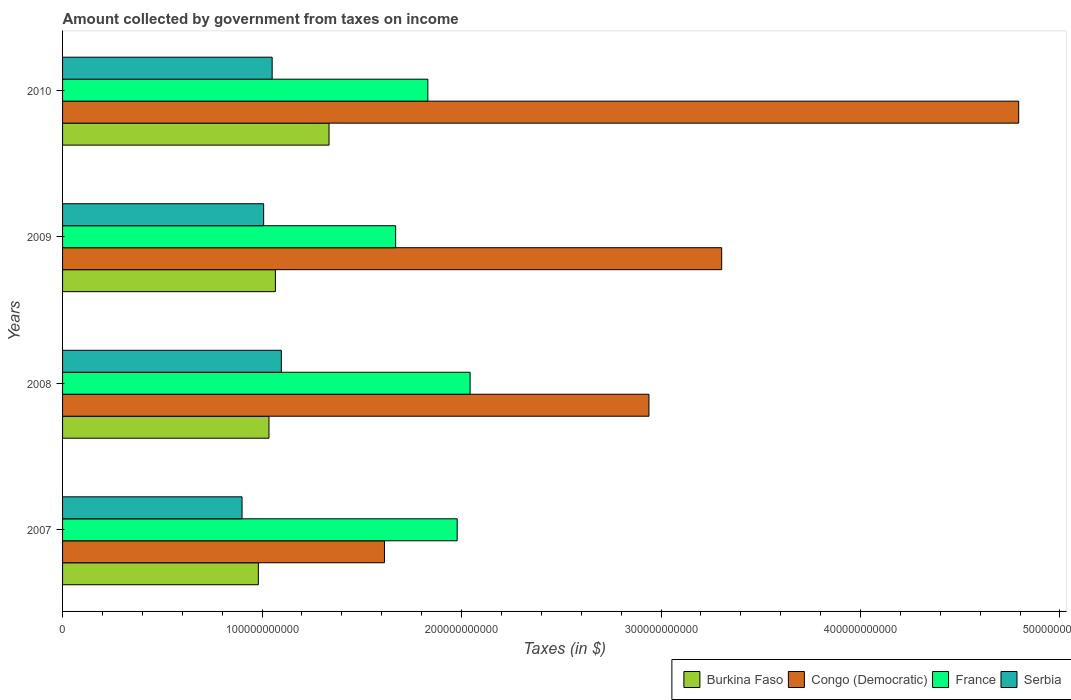How many different coloured bars are there?
Offer a terse response. 4. How many groups of bars are there?
Your response must be concise. 4. In how many cases, is the number of bars for a given year not equal to the number of legend labels?
Your response must be concise. 0. What is the amount collected by government from taxes on income in France in 2009?
Your answer should be compact. 1.67e+11. Across all years, what is the maximum amount collected by government from taxes on income in Burkina Faso?
Offer a very short reply. 1.34e+11. Across all years, what is the minimum amount collected by government from taxes on income in France?
Ensure brevity in your answer.  1.67e+11. In which year was the amount collected by government from taxes on income in Serbia minimum?
Keep it short and to the point. 2007. What is the total amount collected by government from taxes on income in Congo (Democratic) in the graph?
Keep it short and to the point. 1.27e+12. What is the difference between the amount collected by government from taxes on income in Serbia in 2007 and that in 2009?
Ensure brevity in your answer.  -1.08e+1. What is the difference between the amount collected by government from taxes on income in France in 2010 and the amount collected by government from taxes on income in Congo (Democratic) in 2008?
Give a very brief answer. -1.11e+11. What is the average amount collected by government from taxes on income in Congo (Democratic) per year?
Offer a very short reply. 3.16e+11. In the year 2010, what is the difference between the amount collected by government from taxes on income in France and amount collected by government from taxes on income in Serbia?
Provide a short and direct response. 7.80e+1. What is the ratio of the amount collected by government from taxes on income in Burkina Faso in 2008 to that in 2009?
Your answer should be compact. 0.97. Is the amount collected by government from taxes on income in France in 2007 less than that in 2009?
Your answer should be very brief. No. What is the difference between the highest and the second highest amount collected by government from taxes on income in Burkina Faso?
Provide a succinct answer. 2.69e+1. What is the difference between the highest and the lowest amount collected by government from taxes on income in France?
Provide a succinct answer. 3.73e+1. Is the sum of the amount collected by government from taxes on income in Burkina Faso in 2007 and 2008 greater than the maximum amount collected by government from taxes on income in France across all years?
Provide a short and direct response. No. Is it the case that in every year, the sum of the amount collected by government from taxes on income in Congo (Democratic) and amount collected by government from taxes on income in Burkina Faso is greater than the sum of amount collected by government from taxes on income in France and amount collected by government from taxes on income in Serbia?
Make the answer very short. Yes. What does the 4th bar from the top in 2007 represents?
Ensure brevity in your answer.  Burkina Faso. What does the 2nd bar from the bottom in 2008 represents?
Your answer should be compact. Congo (Democratic). Is it the case that in every year, the sum of the amount collected by government from taxes on income in Burkina Faso and amount collected by government from taxes on income in Congo (Democratic) is greater than the amount collected by government from taxes on income in France?
Provide a succinct answer. Yes. Are all the bars in the graph horizontal?
Provide a short and direct response. Yes. What is the difference between two consecutive major ticks on the X-axis?
Your answer should be compact. 1.00e+11. What is the title of the graph?
Make the answer very short. Amount collected by government from taxes on income. What is the label or title of the X-axis?
Provide a short and direct response. Taxes (in $). What is the label or title of the Y-axis?
Keep it short and to the point. Years. What is the Taxes (in $) of Burkina Faso in 2007?
Make the answer very short. 9.82e+1. What is the Taxes (in $) of Congo (Democratic) in 2007?
Your answer should be very brief. 1.61e+11. What is the Taxes (in $) of France in 2007?
Provide a succinct answer. 1.98e+11. What is the Taxes (in $) in Serbia in 2007?
Offer a very short reply. 9.00e+1. What is the Taxes (in $) in Burkina Faso in 2008?
Your answer should be compact. 1.03e+11. What is the Taxes (in $) of Congo (Democratic) in 2008?
Keep it short and to the point. 2.94e+11. What is the Taxes (in $) of France in 2008?
Provide a short and direct response. 2.04e+11. What is the Taxes (in $) in Serbia in 2008?
Offer a terse response. 1.10e+11. What is the Taxes (in $) of Burkina Faso in 2009?
Give a very brief answer. 1.07e+11. What is the Taxes (in $) in Congo (Democratic) in 2009?
Your response must be concise. 3.30e+11. What is the Taxes (in $) in France in 2009?
Your response must be concise. 1.67e+11. What is the Taxes (in $) in Serbia in 2009?
Your answer should be very brief. 1.01e+11. What is the Taxes (in $) in Burkina Faso in 2010?
Your answer should be very brief. 1.34e+11. What is the Taxes (in $) of Congo (Democratic) in 2010?
Ensure brevity in your answer.  4.79e+11. What is the Taxes (in $) in France in 2010?
Make the answer very short. 1.83e+11. What is the Taxes (in $) in Serbia in 2010?
Make the answer very short. 1.05e+11. Across all years, what is the maximum Taxes (in $) in Burkina Faso?
Your response must be concise. 1.34e+11. Across all years, what is the maximum Taxes (in $) of Congo (Democratic)?
Give a very brief answer. 4.79e+11. Across all years, what is the maximum Taxes (in $) of France?
Give a very brief answer. 2.04e+11. Across all years, what is the maximum Taxes (in $) in Serbia?
Your answer should be very brief. 1.10e+11. Across all years, what is the minimum Taxes (in $) in Burkina Faso?
Keep it short and to the point. 9.82e+1. Across all years, what is the minimum Taxes (in $) of Congo (Democratic)?
Keep it short and to the point. 1.61e+11. Across all years, what is the minimum Taxes (in $) of France?
Your answer should be very brief. 1.67e+11. Across all years, what is the minimum Taxes (in $) of Serbia?
Make the answer very short. 9.00e+1. What is the total Taxes (in $) in Burkina Faso in the graph?
Your answer should be very brief. 4.42e+11. What is the total Taxes (in $) in Congo (Democratic) in the graph?
Keep it short and to the point. 1.27e+12. What is the total Taxes (in $) in France in the graph?
Keep it short and to the point. 7.52e+11. What is the total Taxes (in $) of Serbia in the graph?
Offer a terse response. 4.06e+11. What is the difference between the Taxes (in $) in Burkina Faso in 2007 and that in 2008?
Ensure brevity in your answer.  -5.32e+09. What is the difference between the Taxes (in $) of Congo (Democratic) in 2007 and that in 2008?
Keep it short and to the point. -1.33e+11. What is the difference between the Taxes (in $) in France in 2007 and that in 2008?
Ensure brevity in your answer.  -6.48e+09. What is the difference between the Taxes (in $) in Serbia in 2007 and that in 2008?
Offer a terse response. -1.97e+1. What is the difference between the Taxes (in $) in Burkina Faso in 2007 and that in 2009?
Your response must be concise. -8.54e+09. What is the difference between the Taxes (in $) in Congo (Democratic) in 2007 and that in 2009?
Make the answer very short. -1.69e+11. What is the difference between the Taxes (in $) of France in 2007 and that in 2009?
Provide a succinct answer. 3.08e+1. What is the difference between the Taxes (in $) in Serbia in 2007 and that in 2009?
Ensure brevity in your answer.  -1.08e+1. What is the difference between the Taxes (in $) of Burkina Faso in 2007 and that in 2010?
Your answer should be compact. -3.54e+1. What is the difference between the Taxes (in $) of Congo (Democratic) in 2007 and that in 2010?
Your answer should be compact. -3.18e+11. What is the difference between the Taxes (in $) in France in 2007 and that in 2010?
Your answer should be very brief. 1.47e+1. What is the difference between the Taxes (in $) in Serbia in 2007 and that in 2010?
Your answer should be compact. -1.51e+1. What is the difference between the Taxes (in $) of Burkina Faso in 2008 and that in 2009?
Ensure brevity in your answer.  -3.22e+09. What is the difference between the Taxes (in $) of Congo (Democratic) in 2008 and that in 2009?
Your answer should be very brief. -3.65e+1. What is the difference between the Taxes (in $) in France in 2008 and that in 2009?
Your answer should be very brief. 3.73e+1. What is the difference between the Taxes (in $) of Serbia in 2008 and that in 2009?
Your answer should be compact. 8.86e+09. What is the difference between the Taxes (in $) of Burkina Faso in 2008 and that in 2010?
Offer a very short reply. -3.01e+1. What is the difference between the Taxes (in $) in Congo (Democratic) in 2008 and that in 2010?
Your answer should be very brief. -1.85e+11. What is the difference between the Taxes (in $) of France in 2008 and that in 2010?
Ensure brevity in your answer.  2.12e+1. What is the difference between the Taxes (in $) in Serbia in 2008 and that in 2010?
Your answer should be very brief. 4.60e+09. What is the difference between the Taxes (in $) of Burkina Faso in 2009 and that in 2010?
Provide a short and direct response. -2.69e+1. What is the difference between the Taxes (in $) in Congo (Democratic) in 2009 and that in 2010?
Your answer should be very brief. -1.49e+11. What is the difference between the Taxes (in $) of France in 2009 and that in 2010?
Give a very brief answer. -1.61e+1. What is the difference between the Taxes (in $) of Serbia in 2009 and that in 2010?
Make the answer very short. -4.26e+09. What is the difference between the Taxes (in $) of Burkina Faso in 2007 and the Taxes (in $) of Congo (Democratic) in 2008?
Your answer should be very brief. -1.96e+11. What is the difference between the Taxes (in $) of Burkina Faso in 2007 and the Taxes (in $) of France in 2008?
Your answer should be compact. -1.06e+11. What is the difference between the Taxes (in $) in Burkina Faso in 2007 and the Taxes (in $) in Serbia in 2008?
Ensure brevity in your answer.  -1.15e+1. What is the difference between the Taxes (in $) in Congo (Democratic) in 2007 and the Taxes (in $) in France in 2008?
Your response must be concise. -4.29e+1. What is the difference between the Taxes (in $) in Congo (Democratic) in 2007 and the Taxes (in $) in Serbia in 2008?
Provide a short and direct response. 5.17e+1. What is the difference between the Taxes (in $) in France in 2007 and the Taxes (in $) in Serbia in 2008?
Offer a terse response. 8.82e+1. What is the difference between the Taxes (in $) of Burkina Faso in 2007 and the Taxes (in $) of Congo (Democratic) in 2009?
Your response must be concise. -2.32e+11. What is the difference between the Taxes (in $) in Burkina Faso in 2007 and the Taxes (in $) in France in 2009?
Offer a very short reply. -6.88e+1. What is the difference between the Taxes (in $) of Burkina Faso in 2007 and the Taxes (in $) of Serbia in 2009?
Your answer should be very brief. -2.65e+09. What is the difference between the Taxes (in $) of Congo (Democratic) in 2007 and the Taxes (in $) of France in 2009?
Your answer should be very brief. -5.61e+09. What is the difference between the Taxes (in $) in Congo (Democratic) in 2007 and the Taxes (in $) in Serbia in 2009?
Make the answer very short. 6.06e+1. What is the difference between the Taxes (in $) in France in 2007 and the Taxes (in $) in Serbia in 2009?
Ensure brevity in your answer.  9.70e+1. What is the difference between the Taxes (in $) of Burkina Faso in 2007 and the Taxes (in $) of Congo (Democratic) in 2010?
Provide a succinct answer. -3.81e+11. What is the difference between the Taxes (in $) in Burkina Faso in 2007 and the Taxes (in $) in France in 2010?
Your response must be concise. -8.50e+1. What is the difference between the Taxes (in $) in Burkina Faso in 2007 and the Taxes (in $) in Serbia in 2010?
Give a very brief answer. -6.92e+09. What is the difference between the Taxes (in $) in Congo (Democratic) in 2007 and the Taxes (in $) in France in 2010?
Your response must be concise. -2.17e+1. What is the difference between the Taxes (in $) in Congo (Democratic) in 2007 and the Taxes (in $) in Serbia in 2010?
Offer a terse response. 5.63e+1. What is the difference between the Taxes (in $) in France in 2007 and the Taxes (in $) in Serbia in 2010?
Your answer should be compact. 9.28e+1. What is the difference between the Taxes (in $) of Burkina Faso in 2008 and the Taxes (in $) of Congo (Democratic) in 2009?
Offer a very short reply. -2.27e+11. What is the difference between the Taxes (in $) of Burkina Faso in 2008 and the Taxes (in $) of France in 2009?
Your answer should be very brief. -6.35e+1. What is the difference between the Taxes (in $) of Burkina Faso in 2008 and the Taxes (in $) of Serbia in 2009?
Give a very brief answer. 2.67e+09. What is the difference between the Taxes (in $) of Congo (Democratic) in 2008 and the Taxes (in $) of France in 2009?
Make the answer very short. 1.27e+11. What is the difference between the Taxes (in $) of Congo (Democratic) in 2008 and the Taxes (in $) of Serbia in 2009?
Keep it short and to the point. 1.93e+11. What is the difference between the Taxes (in $) in France in 2008 and the Taxes (in $) in Serbia in 2009?
Provide a succinct answer. 1.03e+11. What is the difference between the Taxes (in $) in Burkina Faso in 2008 and the Taxes (in $) in Congo (Democratic) in 2010?
Your response must be concise. -3.76e+11. What is the difference between the Taxes (in $) of Burkina Faso in 2008 and the Taxes (in $) of France in 2010?
Provide a succinct answer. -7.96e+1. What is the difference between the Taxes (in $) of Burkina Faso in 2008 and the Taxes (in $) of Serbia in 2010?
Provide a short and direct response. -1.60e+09. What is the difference between the Taxes (in $) in Congo (Democratic) in 2008 and the Taxes (in $) in France in 2010?
Provide a succinct answer. 1.11e+11. What is the difference between the Taxes (in $) in Congo (Democratic) in 2008 and the Taxes (in $) in Serbia in 2010?
Offer a terse response. 1.89e+11. What is the difference between the Taxes (in $) in France in 2008 and the Taxes (in $) in Serbia in 2010?
Provide a succinct answer. 9.92e+1. What is the difference between the Taxes (in $) of Burkina Faso in 2009 and the Taxes (in $) of Congo (Democratic) in 2010?
Ensure brevity in your answer.  -3.73e+11. What is the difference between the Taxes (in $) in Burkina Faso in 2009 and the Taxes (in $) in France in 2010?
Offer a very short reply. -7.64e+1. What is the difference between the Taxes (in $) of Burkina Faso in 2009 and the Taxes (in $) of Serbia in 2010?
Your answer should be compact. 1.62e+09. What is the difference between the Taxes (in $) in Congo (Democratic) in 2009 and the Taxes (in $) in France in 2010?
Keep it short and to the point. 1.47e+11. What is the difference between the Taxes (in $) in Congo (Democratic) in 2009 and the Taxes (in $) in Serbia in 2010?
Keep it short and to the point. 2.25e+11. What is the difference between the Taxes (in $) of France in 2009 and the Taxes (in $) of Serbia in 2010?
Your answer should be compact. 6.19e+1. What is the average Taxes (in $) in Burkina Faso per year?
Your answer should be very brief. 1.10e+11. What is the average Taxes (in $) of Congo (Democratic) per year?
Offer a terse response. 3.16e+11. What is the average Taxes (in $) in France per year?
Make the answer very short. 1.88e+11. What is the average Taxes (in $) in Serbia per year?
Your response must be concise. 1.01e+11. In the year 2007, what is the difference between the Taxes (in $) in Burkina Faso and Taxes (in $) in Congo (Democratic)?
Your response must be concise. -6.32e+1. In the year 2007, what is the difference between the Taxes (in $) of Burkina Faso and Taxes (in $) of France?
Your response must be concise. -9.97e+1. In the year 2007, what is the difference between the Taxes (in $) in Burkina Faso and Taxes (in $) in Serbia?
Keep it short and to the point. 8.18e+09. In the year 2007, what is the difference between the Taxes (in $) of Congo (Democratic) and Taxes (in $) of France?
Ensure brevity in your answer.  -3.64e+1. In the year 2007, what is the difference between the Taxes (in $) in Congo (Democratic) and Taxes (in $) in Serbia?
Your answer should be very brief. 7.14e+1. In the year 2007, what is the difference between the Taxes (in $) of France and Taxes (in $) of Serbia?
Provide a succinct answer. 1.08e+11. In the year 2008, what is the difference between the Taxes (in $) in Burkina Faso and Taxes (in $) in Congo (Democratic)?
Ensure brevity in your answer.  -1.90e+11. In the year 2008, what is the difference between the Taxes (in $) of Burkina Faso and Taxes (in $) of France?
Make the answer very short. -1.01e+11. In the year 2008, what is the difference between the Taxes (in $) in Burkina Faso and Taxes (in $) in Serbia?
Your response must be concise. -6.19e+09. In the year 2008, what is the difference between the Taxes (in $) of Congo (Democratic) and Taxes (in $) of France?
Your answer should be very brief. 8.97e+1. In the year 2008, what is the difference between the Taxes (in $) of Congo (Democratic) and Taxes (in $) of Serbia?
Your answer should be very brief. 1.84e+11. In the year 2008, what is the difference between the Taxes (in $) in France and Taxes (in $) in Serbia?
Ensure brevity in your answer.  9.46e+1. In the year 2009, what is the difference between the Taxes (in $) of Burkina Faso and Taxes (in $) of Congo (Democratic)?
Provide a short and direct response. -2.24e+11. In the year 2009, what is the difference between the Taxes (in $) in Burkina Faso and Taxes (in $) in France?
Your answer should be very brief. -6.03e+1. In the year 2009, what is the difference between the Taxes (in $) of Burkina Faso and Taxes (in $) of Serbia?
Provide a short and direct response. 5.88e+09. In the year 2009, what is the difference between the Taxes (in $) in Congo (Democratic) and Taxes (in $) in France?
Provide a short and direct response. 1.63e+11. In the year 2009, what is the difference between the Taxes (in $) of Congo (Democratic) and Taxes (in $) of Serbia?
Keep it short and to the point. 2.30e+11. In the year 2009, what is the difference between the Taxes (in $) of France and Taxes (in $) of Serbia?
Ensure brevity in your answer.  6.62e+1. In the year 2010, what is the difference between the Taxes (in $) of Burkina Faso and Taxes (in $) of Congo (Democratic)?
Give a very brief answer. -3.46e+11. In the year 2010, what is the difference between the Taxes (in $) in Burkina Faso and Taxes (in $) in France?
Provide a succinct answer. -4.95e+1. In the year 2010, what is the difference between the Taxes (in $) of Burkina Faso and Taxes (in $) of Serbia?
Your answer should be compact. 2.85e+1. In the year 2010, what is the difference between the Taxes (in $) in Congo (Democratic) and Taxes (in $) in France?
Ensure brevity in your answer.  2.96e+11. In the year 2010, what is the difference between the Taxes (in $) in Congo (Democratic) and Taxes (in $) in Serbia?
Offer a terse response. 3.74e+11. In the year 2010, what is the difference between the Taxes (in $) of France and Taxes (in $) of Serbia?
Make the answer very short. 7.80e+1. What is the ratio of the Taxes (in $) of Burkina Faso in 2007 to that in 2008?
Your answer should be very brief. 0.95. What is the ratio of the Taxes (in $) of Congo (Democratic) in 2007 to that in 2008?
Provide a short and direct response. 0.55. What is the ratio of the Taxes (in $) of France in 2007 to that in 2008?
Keep it short and to the point. 0.97. What is the ratio of the Taxes (in $) in Serbia in 2007 to that in 2008?
Give a very brief answer. 0.82. What is the ratio of the Taxes (in $) of Congo (Democratic) in 2007 to that in 2009?
Keep it short and to the point. 0.49. What is the ratio of the Taxes (in $) in France in 2007 to that in 2009?
Provide a succinct answer. 1.18. What is the ratio of the Taxes (in $) of Serbia in 2007 to that in 2009?
Ensure brevity in your answer.  0.89. What is the ratio of the Taxes (in $) in Burkina Faso in 2007 to that in 2010?
Your response must be concise. 0.73. What is the ratio of the Taxes (in $) in Congo (Democratic) in 2007 to that in 2010?
Make the answer very short. 0.34. What is the ratio of the Taxes (in $) of France in 2007 to that in 2010?
Ensure brevity in your answer.  1.08. What is the ratio of the Taxes (in $) in Serbia in 2007 to that in 2010?
Give a very brief answer. 0.86. What is the ratio of the Taxes (in $) of Burkina Faso in 2008 to that in 2009?
Make the answer very short. 0.97. What is the ratio of the Taxes (in $) in Congo (Democratic) in 2008 to that in 2009?
Provide a succinct answer. 0.89. What is the ratio of the Taxes (in $) in France in 2008 to that in 2009?
Offer a very short reply. 1.22. What is the ratio of the Taxes (in $) of Serbia in 2008 to that in 2009?
Keep it short and to the point. 1.09. What is the ratio of the Taxes (in $) in Burkina Faso in 2008 to that in 2010?
Your answer should be very brief. 0.77. What is the ratio of the Taxes (in $) of Congo (Democratic) in 2008 to that in 2010?
Your answer should be very brief. 0.61. What is the ratio of the Taxes (in $) of France in 2008 to that in 2010?
Offer a very short reply. 1.12. What is the ratio of the Taxes (in $) in Serbia in 2008 to that in 2010?
Your answer should be compact. 1.04. What is the ratio of the Taxes (in $) in Burkina Faso in 2009 to that in 2010?
Ensure brevity in your answer.  0.8. What is the ratio of the Taxes (in $) of Congo (Democratic) in 2009 to that in 2010?
Your answer should be very brief. 0.69. What is the ratio of the Taxes (in $) in France in 2009 to that in 2010?
Your answer should be very brief. 0.91. What is the ratio of the Taxes (in $) of Serbia in 2009 to that in 2010?
Your answer should be compact. 0.96. What is the difference between the highest and the second highest Taxes (in $) of Burkina Faso?
Your answer should be very brief. 2.69e+1. What is the difference between the highest and the second highest Taxes (in $) of Congo (Democratic)?
Your answer should be compact. 1.49e+11. What is the difference between the highest and the second highest Taxes (in $) of France?
Your response must be concise. 6.48e+09. What is the difference between the highest and the second highest Taxes (in $) in Serbia?
Your answer should be compact. 4.60e+09. What is the difference between the highest and the lowest Taxes (in $) in Burkina Faso?
Keep it short and to the point. 3.54e+1. What is the difference between the highest and the lowest Taxes (in $) in Congo (Democratic)?
Your answer should be very brief. 3.18e+11. What is the difference between the highest and the lowest Taxes (in $) of France?
Your response must be concise. 3.73e+1. What is the difference between the highest and the lowest Taxes (in $) in Serbia?
Provide a short and direct response. 1.97e+1. 